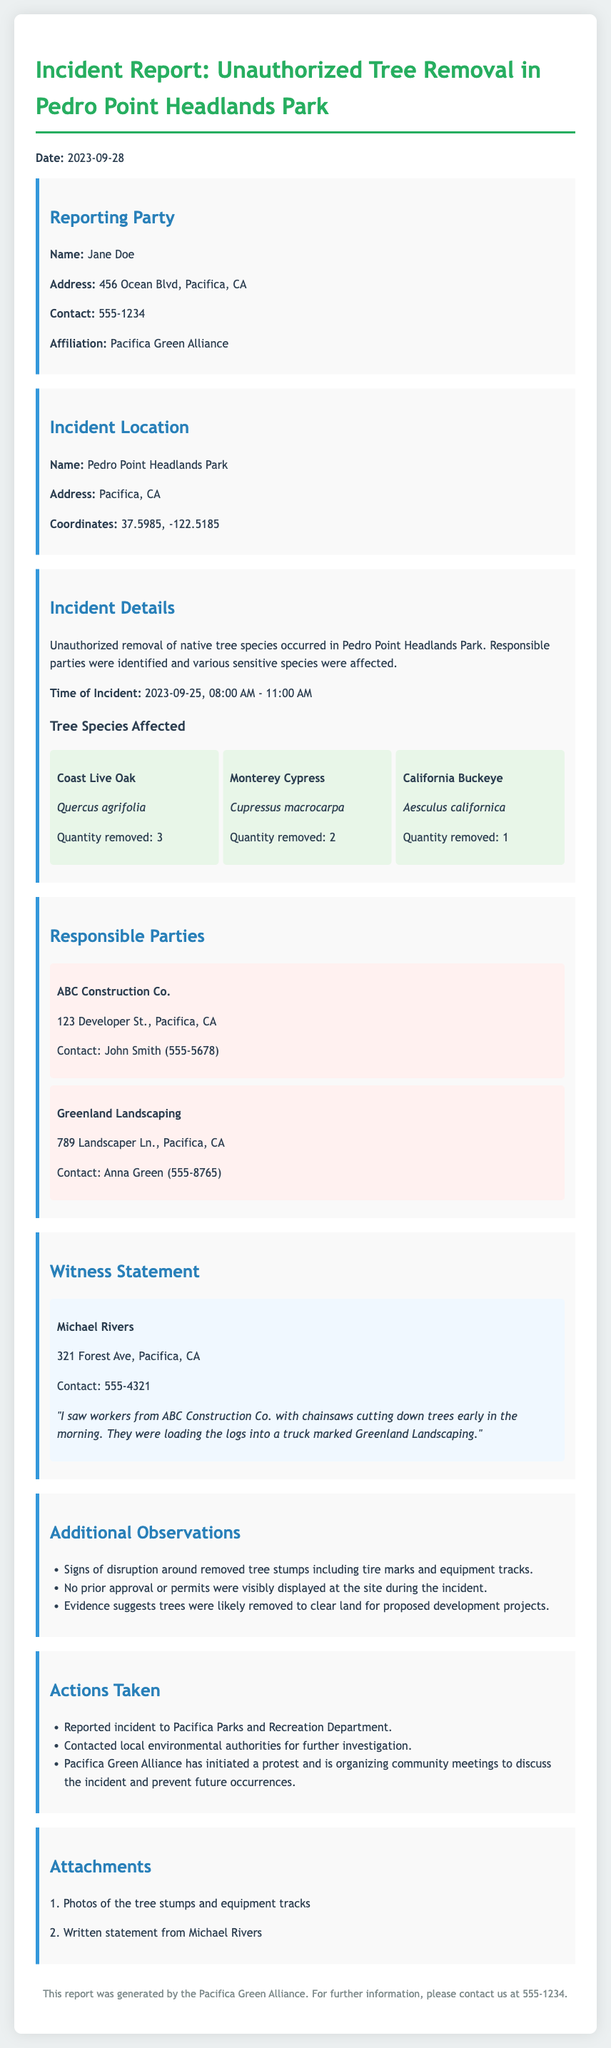What is the date of the incident? The date of the incident is specified at the beginning of the document as 2023-09-28.
Answer: 2023-09-28 Who reported the incident? The reporting party's name is mentioned in the section for reporting parties, which is Jane Doe.
Answer: Jane Doe How many Coast Live Oak trees were removed? The quantity of Coast Live Oak trees that were removed is stated in the tree species section, which is 3.
Answer: 3 What company is listed as a responsible party? One of the responsible parties mentioned in the responsible parties section is ABC Construction Co.
Answer: ABC Construction Co What did the witness see? The witness statement includes a specific observation that workers from ABC Construction Co. were cutting down trees.
Answer: Workers from ABC Construction Co Was there evidence of permissions at the site? The additional observations section indicates that no prior approval or permits were visibly displayed at the site.
Answer: No How many total tree species were mentioned in the incident report? The number of different tree species affected is listed in the tree species section, totaling three: Coast Live Oak, Monterey Cypress, and California Buckeye.
Answer: 3 Who stated the witness account? The witness statement section identifies the person providing the account as Michael Rivers.
Answer: Michael Rivers What action was taken after the incident was reported? The actions taken include reporting the incident to the Pacifica Parks and Recreation Department.
Answer: Reported to Pacifica Parks and Recreation Department What is the affiliation of the reporting party? The affiliation of Jane Doe, the reporting party, is stated as Pacifica Green Alliance.
Answer: Pacifica Green Alliance 